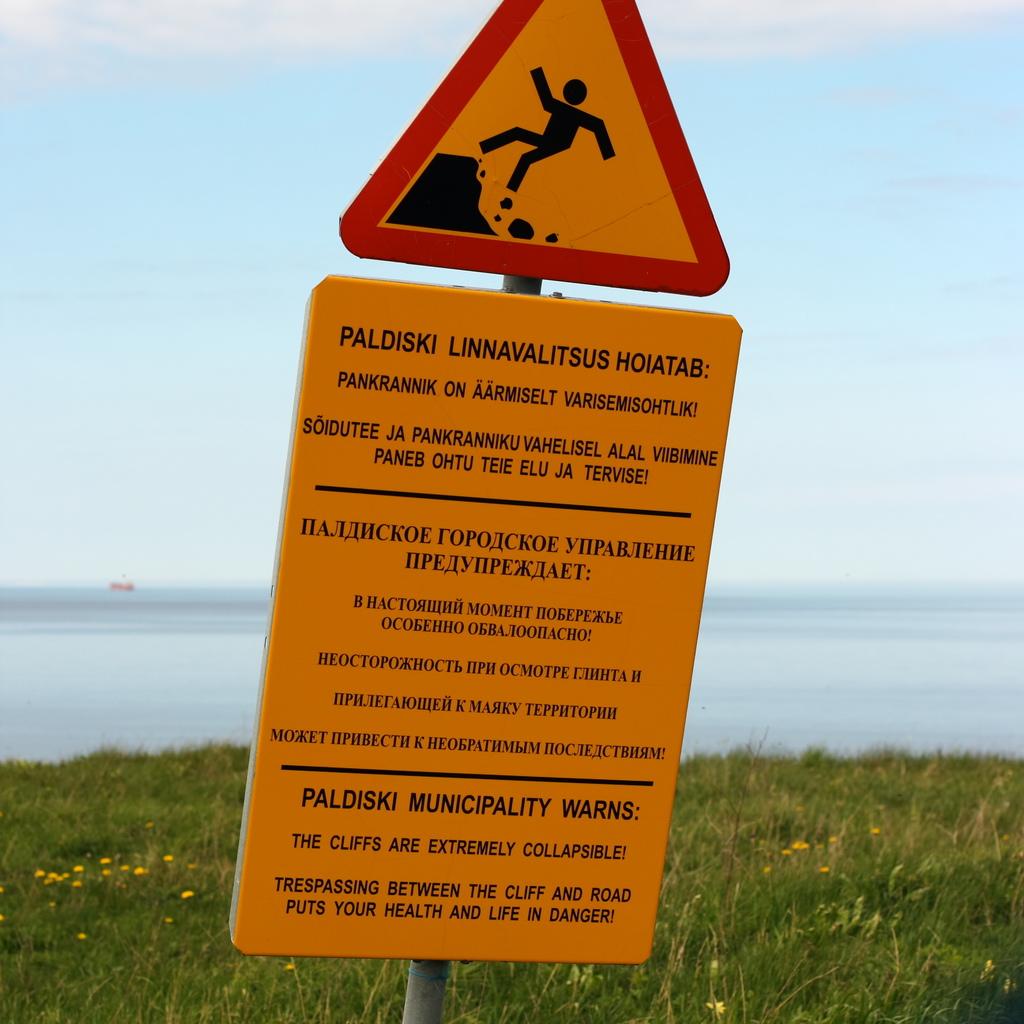What is the sign warning of?
Ensure brevity in your answer.  The cliffs are collapsable. The cliffs are extremely what?
Make the answer very short. Collapsible. 